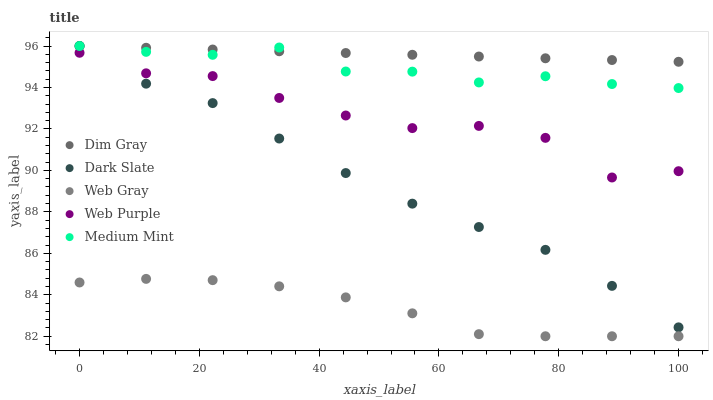Does Web Gray have the minimum area under the curve?
Answer yes or no. Yes. Does Dim Gray have the maximum area under the curve?
Answer yes or no. Yes. Does Dark Slate have the minimum area under the curve?
Answer yes or no. No. Does Dark Slate have the maximum area under the curve?
Answer yes or no. No. Is Dim Gray the smoothest?
Answer yes or no. Yes. Is Web Purple the roughest?
Answer yes or no. Yes. Is Dark Slate the smoothest?
Answer yes or no. No. Is Dark Slate the roughest?
Answer yes or no. No. Does Web Gray have the lowest value?
Answer yes or no. Yes. Does Dark Slate have the lowest value?
Answer yes or no. No. Does Dim Gray have the highest value?
Answer yes or no. Yes. Does Web Purple have the highest value?
Answer yes or no. No. Is Web Gray less than Web Purple?
Answer yes or no. Yes. Is Dark Slate greater than Web Gray?
Answer yes or no. Yes. Does Dim Gray intersect Medium Mint?
Answer yes or no. Yes. Is Dim Gray less than Medium Mint?
Answer yes or no. No. Is Dim Gray greater than Medium Mint?
Answer yes or no. No. Does Web Gray intersect Web Purple?
Answer yes or no. No. 